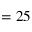Convert formula to latex. <formula><loc_0><loc_0><loc_500><loc_500>= 2 5</formula> 